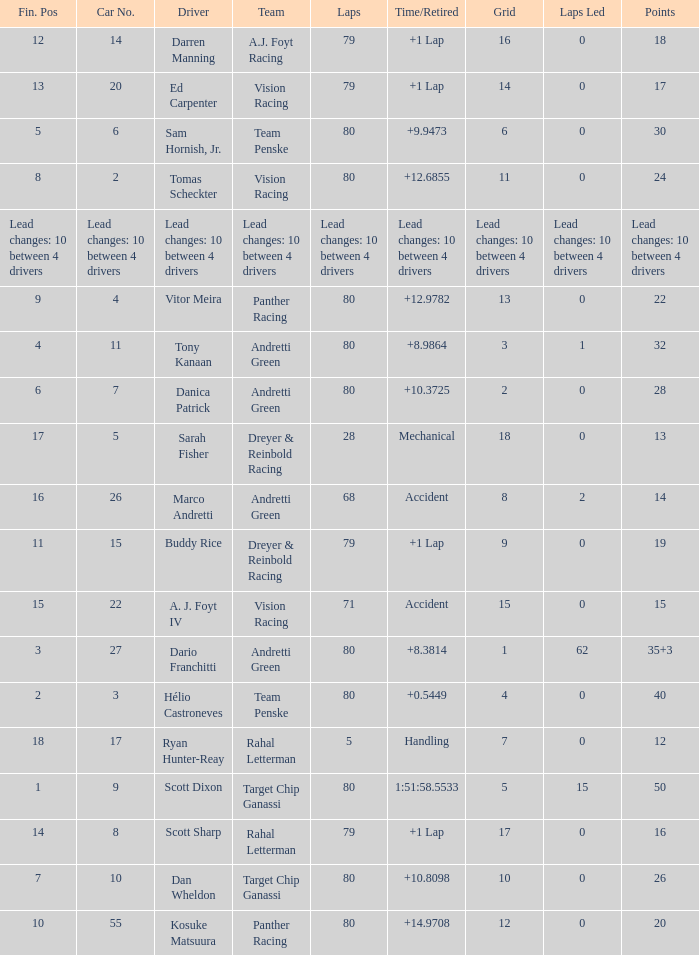What network has 24 points? 11.0. 